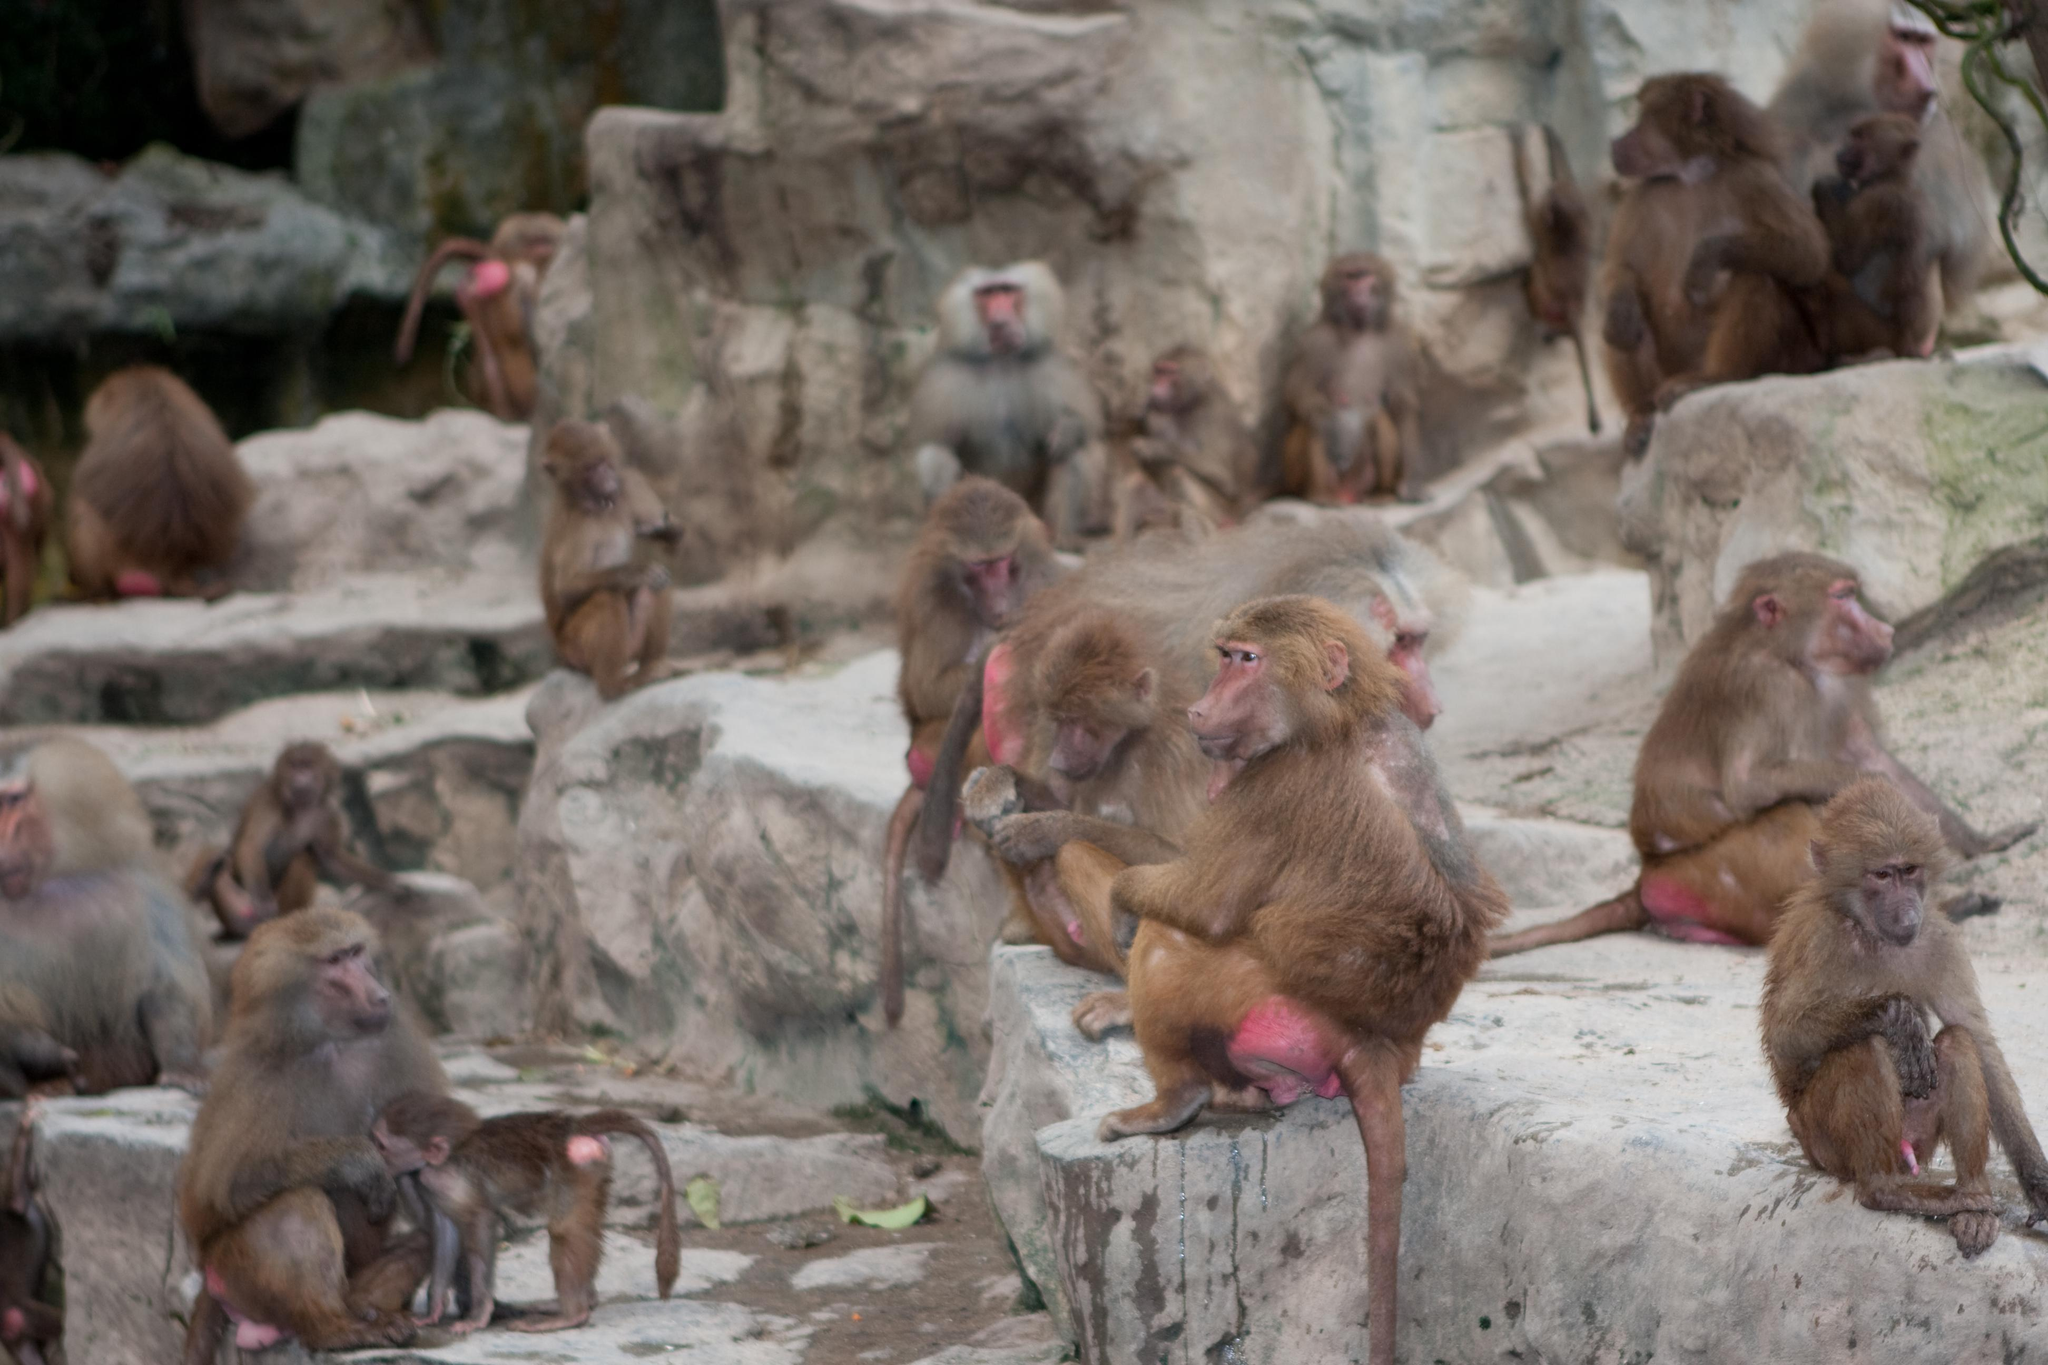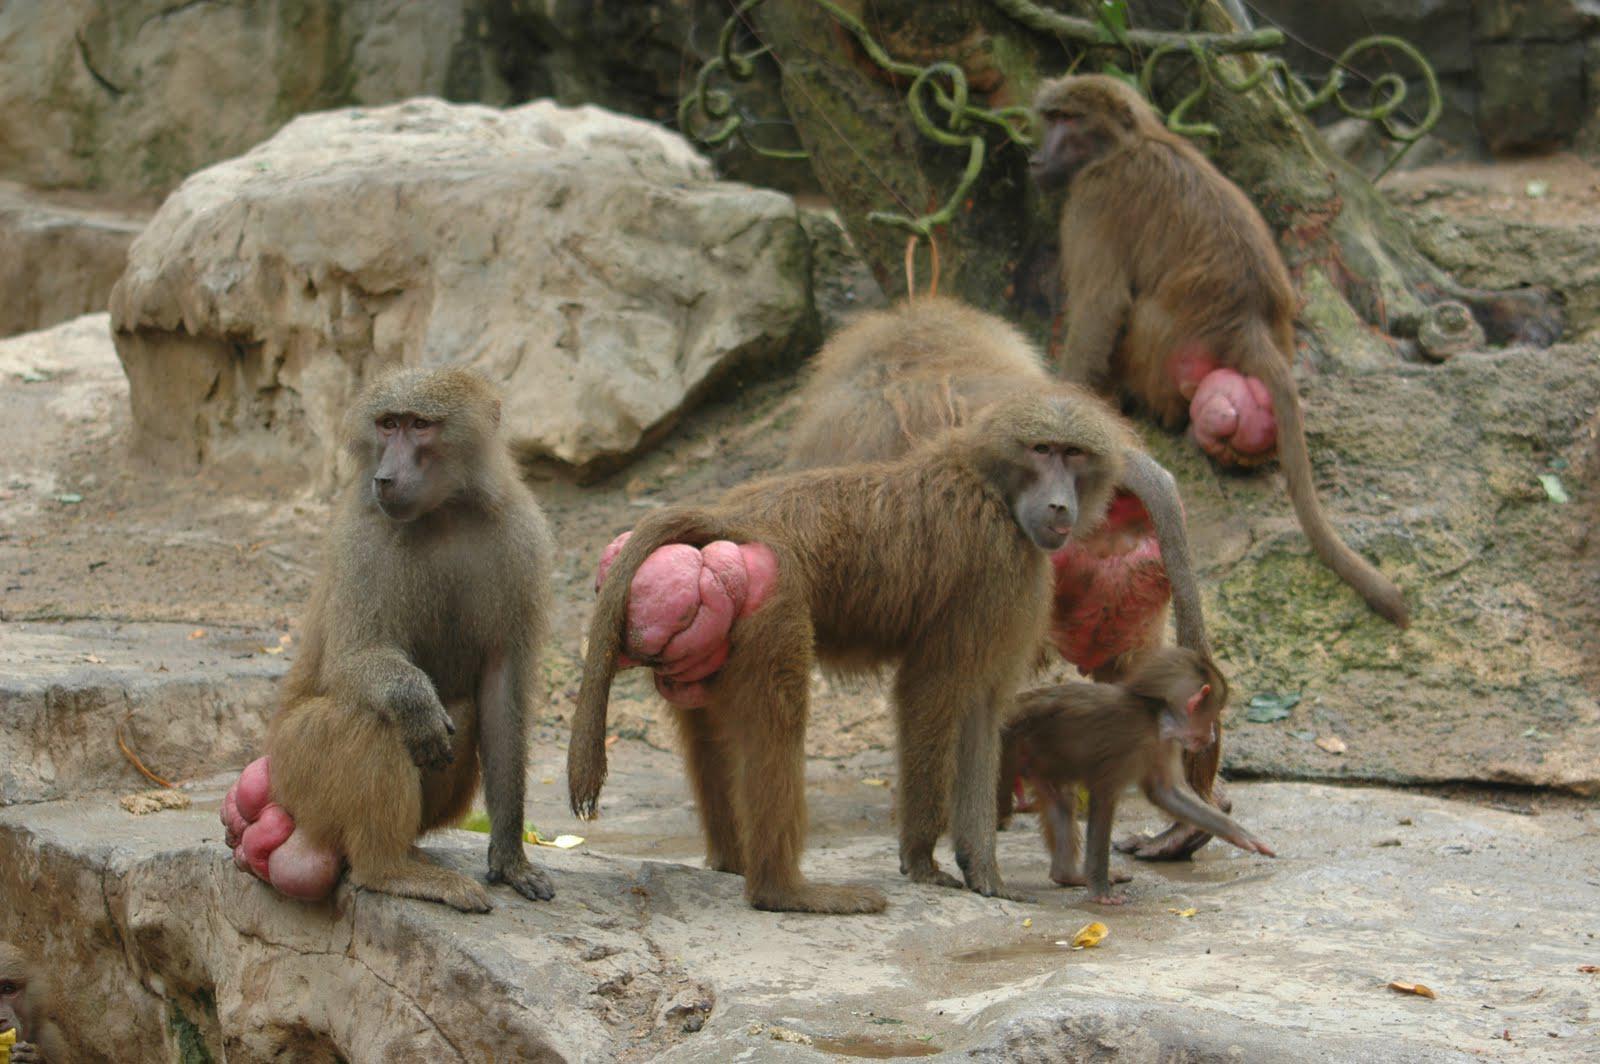The first image is the image on the left, the second image is the image on the right. Examine the images to the left and right. Is the description "Multiple baboons sit on tiered rocks in at least one image." accurate? Answer yes or no. Yes. The first image is the image on the left, the second image is the image on the right. Evaluate the accuracy of this statement regarding the images: "One of the images contains no more than five monkeys". Is it true? Answer yes or no. Yes. 